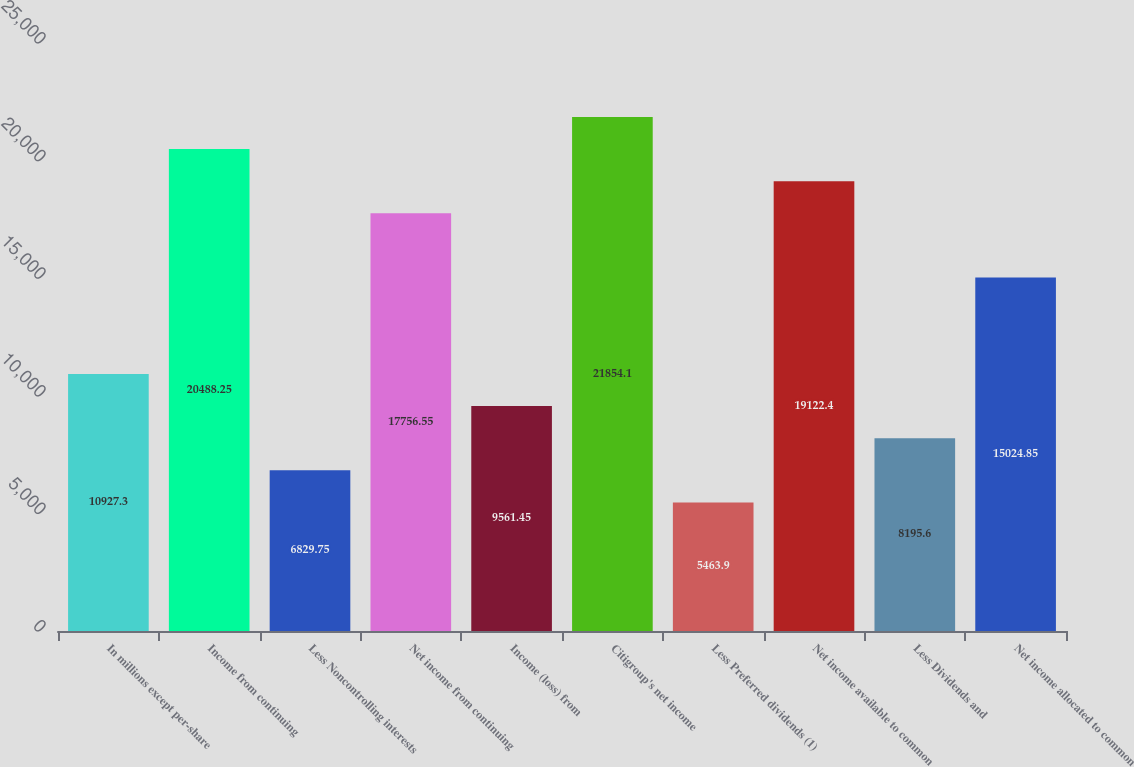Convert chart to OTSL. <chart><loc_0><loc_0><loc_500><loc_500><bar_chart><fcel>In millions except per-share<fcel>Income from continuing<fcel>Less Noncontrolling interests<fcel>Net income from continuing<fcel>Income (loss) from<fcel>Citigroup's net income<fcel>Less Preferred dividends (1)<fcel>Net income available to common<fcel>Less Dividends and<fcel>Net income allocated to common<nl><fcel>10927.3<fcel>20488.2<fcel>6829.75<fcel>17756.5<fcel>9561.45<fcel>21854.1<fcel>5463.9<fcel>19122.4<fcel>8195.6<fcel>15024.9<nl></chart> 